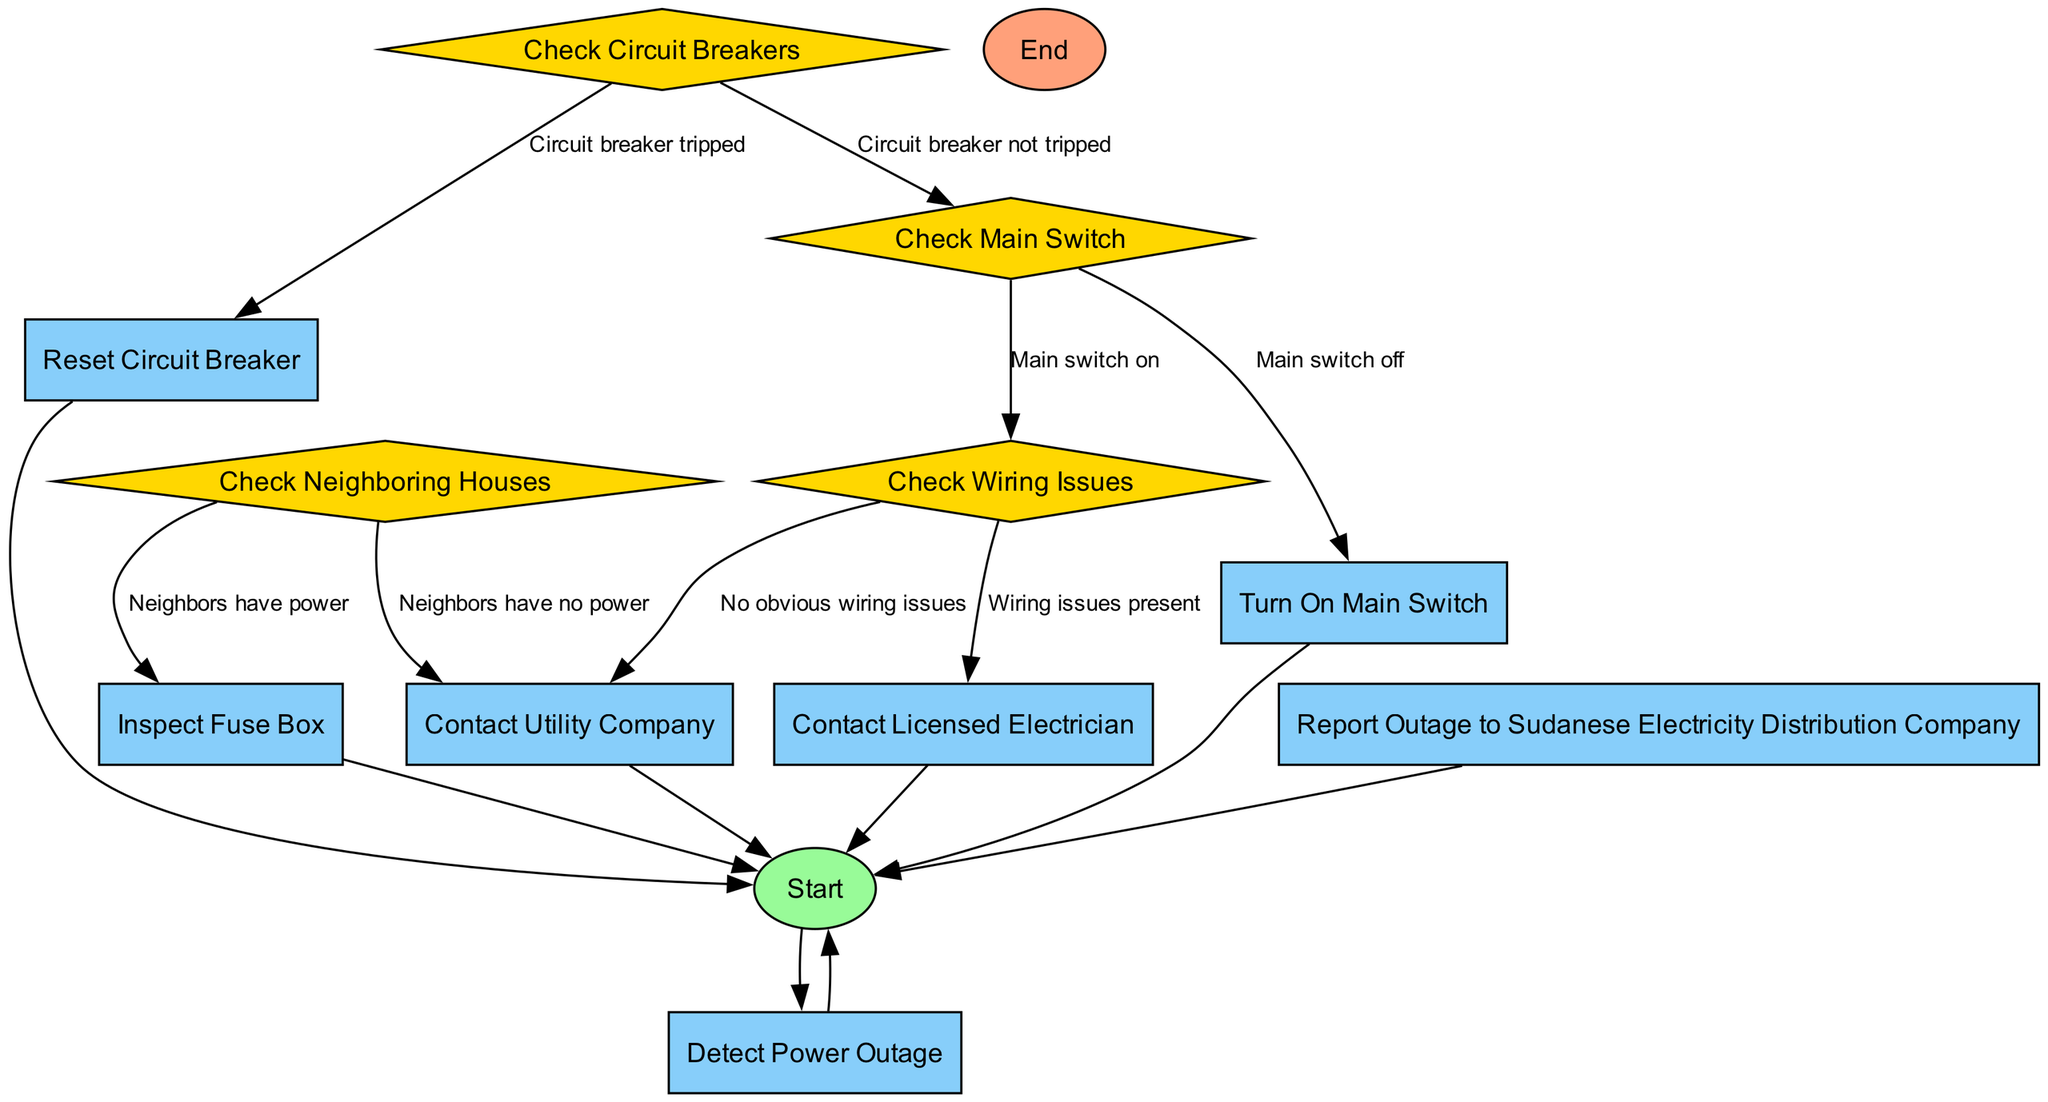What is the first activity in the diagram? The diagram starts with the "Start" event, which represents the initiation of the process. Following that, the first activity is "Detect Power Outage".
Answer: Detect Power Outage How many decision points are present in the diagram? The diagram contains four decision nodes: "Check Neighboring Houses", "Check Circuit Breakers", "Check Main Switch", and "Check Wiring Issues", which adds up to four decision points.
Answer: Four What happens if neighbors have no power? According to the diagram, if neighbors have no power, the next step is to "Contact Utility Company" after detecting the power outage.
Answer: Contact Utility Company What is the final step before ending the process? The last activity conducted before reaching the end is "Contact Utility Company", where the individual communicates with the utility service regarding the outage.
Answer: Contact Utility Company What decision follows the "Inspect Fuse Box" activity? After the "Inspect Fuse Box", the next decision point is "Check Circuit Breakers", where it is determined if the circuit breaker has tripped or not.
Answer: Check Circuit Breakers What must be done if wiring issues are present? If wiring issues are indicated, the next action is to "Contact Licensed Electrician" for professional help.
Answer: Contact Licensed Electrician What is the consequence of a tripped circuit breaker? If the circuit breaker is tripped, the immediate action is to "Reset Circuit Breaker" before continuing the troubleshooting process.
Answer: Reset Circuit Breaker What is the last event in the diagram? The final event indicated in the diagram is the "End" event, which signifies the conclusion of the process after all necessary interactions and actions have been taken.
Answer: End 